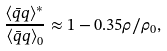Convert formula to latex. <formula><loc_0><loc_0><loc_500><loc_500>\frac { \langle \bar { q } q \rangle ^ { * } } { \langle \bar { q } q \rangle _ { 0 } } \approx 1 - 0 . 3 5 \rho / \rho _ { 0 } ,</formula> 